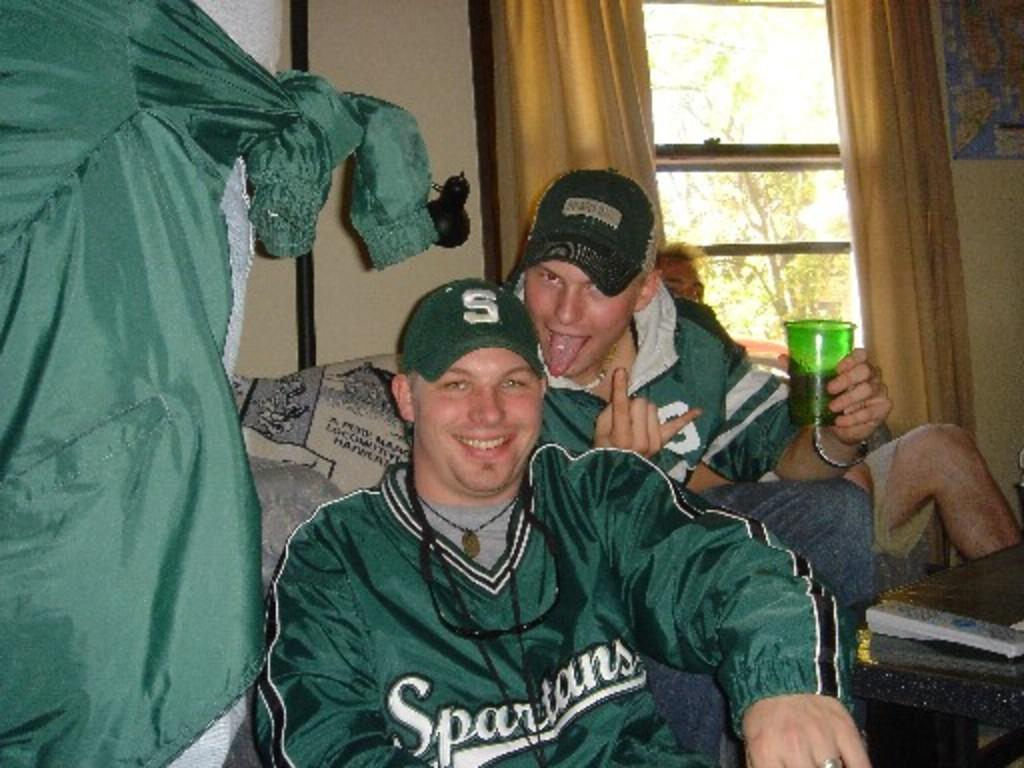<image>
Summarize the visual content of the image. Two boys wear green Spartans  shirts and jackets. 